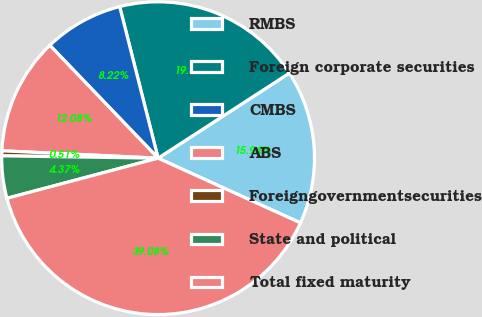Convert chart. <chart><loc_0><loc_0><loc_500><loc_500><pie_chart><fcel>RMBS<fcel>Foreign corporate securities<fcel>CMBS<fcel>ABS<fcel>Foreigngovernmentsecurities<fcel>State and political<fcel>Total fixed maturity<nl><fcel>15.94%<fcel>19.8%<fcel>8.22%<fcel>12.08%<fcel>0.51%<fcel>4.37%<fcel>39.08%<nl></chart> 